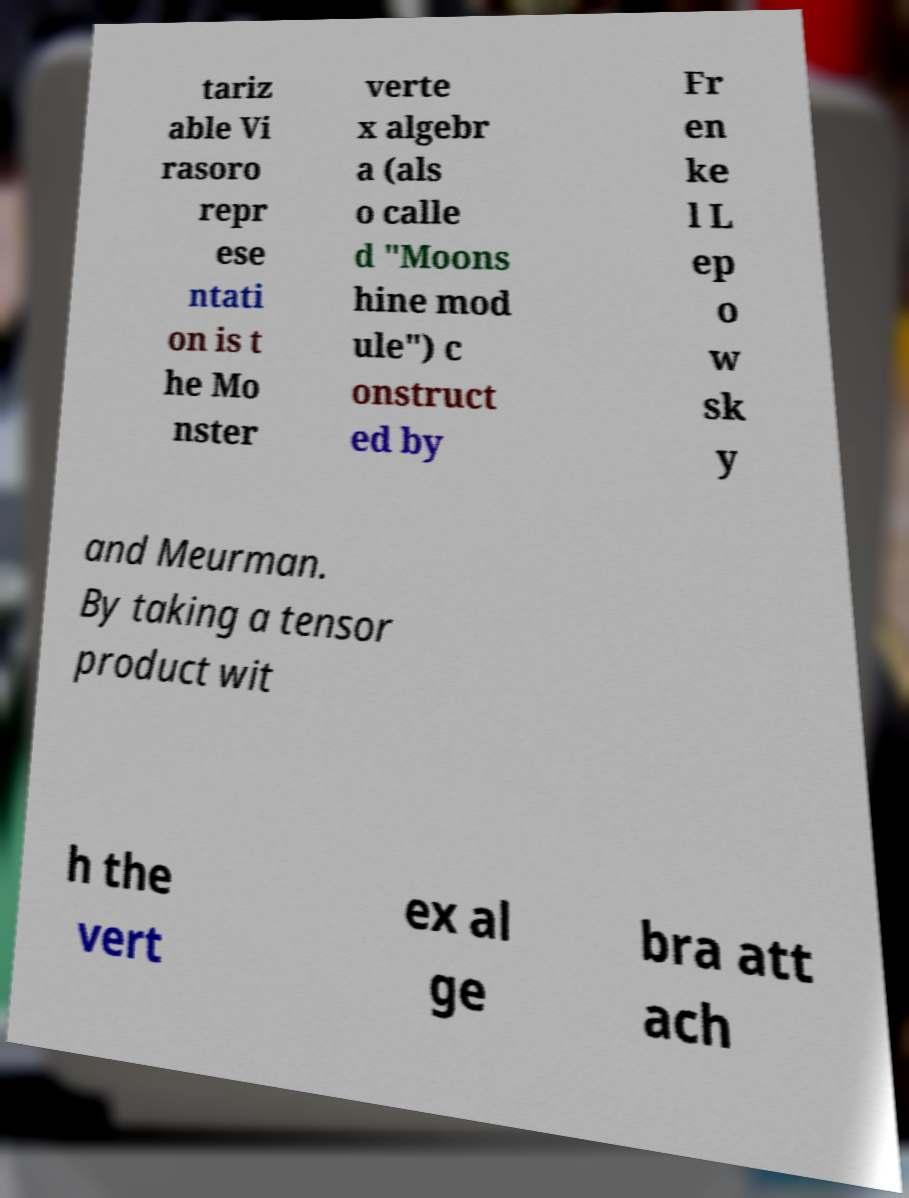What messages or text are displayed in this image? I need them in a readable, typed format. tariz able Vi rasoro repr ese ntati on is t he Mo nster verte x algebr a (als o calle d "Moons hine mod ule") c onstruct ed by Fr en ke l L ep o w sk y and Meurman. By taking a tensor product wit h the vert ex al ge bra att ach 